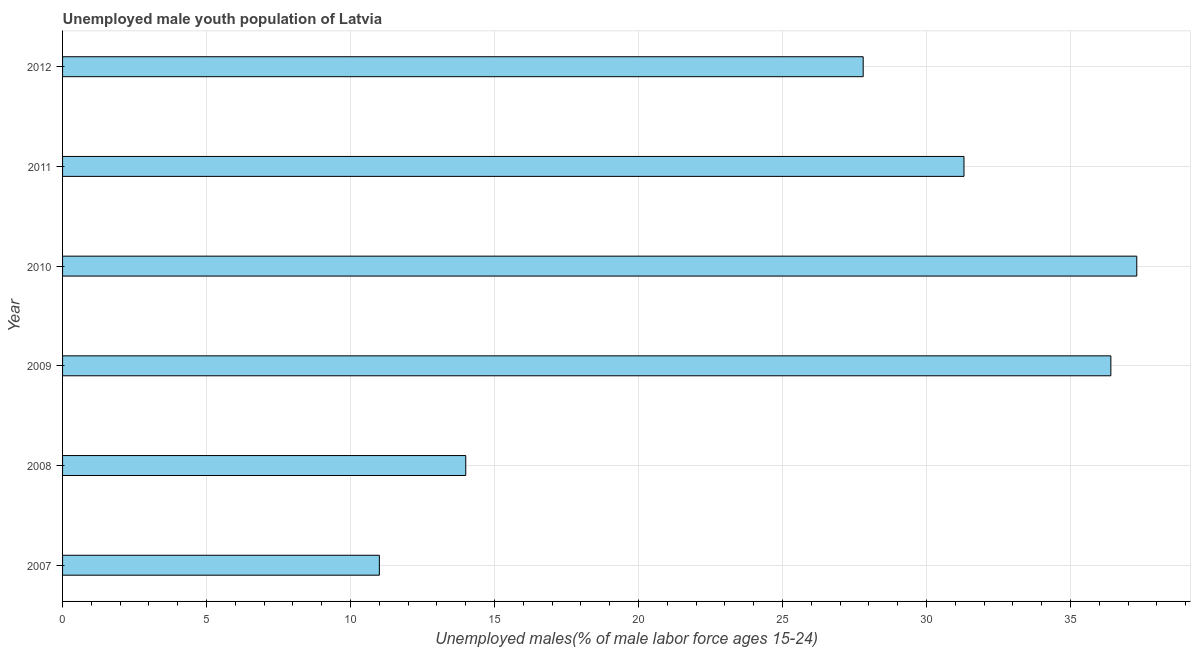Does the graph contain any zero values?
Offer a very short reply. No. Does the graph contain grids?
Make the answer very short. Yes. What is the title of the graph?
Ensure brevity in your answer.  Unemployed male youth population of Latvia. What is the label or title of the X-axis?
Give a very brief answer. Unemployed males(% of male labor force ages 15-24). What is the unemployed male youth in 2010?
Give a very brief answer. 37.3. Across all years, what is the maximum unemployed male youth?
Make the answer very short. 37.3. What is the sum of the unemployed male youth?
Offer a terse response. 157.8. What is the difference between the unemployed male youth in 2007 and 2011?
Offer a very short reply. -20.3. What is the average unemployed male youth per year?
Ensure brevity in your answer.  26.3. What is the median unemployed male youth?
Keep it short and to the point. 29.55. Do a majority of the years between 2008 and 2012 (inclusive) have unemployed male youth greater than 27 %?
Your response must be concise. Yes. What is the ratio of the unemployed male youth in 2010 to that in 2012?
Make the answer very short. 1.34. Is the unemployed male youth in 2009 less than that in 2012?
Offer a terse response. No. What is the difference between the highest and the second highest unemployed male youth?
Offer a terse response. 0.9. What is the difference between the highest and the lowest unemployed male youth?
Your response must be concise. 26.3. In how many years, is the unemployed male youth greater than the average unemployed male youth taken over all years?
Offer a terse response. 4. How many bars are there?
Provide a short and direct response. 6. How many years are there in the graph?
Your answer should be very brief. 6. What is the difference between two consecutive major ticks on the X-axis?
Provide a succinct answer. 5. What is the Unemployed males(% of male labor force ages 15-24) of 2007?
Offer a very short reply. 11. What is the Unemployed males(% of male labor force ages 15-24) of 2009?
Give a very brief answer. 36.4. What is the Unemployed males(% of male labor force ages 15-24) of 2010?
Your answer should be very brief. 37.3. What is the Unemployed males(% of male labor force ages 15-24) in 2011?
Offer a terse response. 31.3. What is the Unemployed males(% of male labor force ages 15-24) of 2012?
Ensure brevity in your answer.  27.8. What is the difference between the Unemployed males(% of male labor force ages 15-24) in 2007 and 2008?
Give a very brief answer. -3. What is the difference between the Unemployed males(% of male labor force ages 15-24) in 2007 and 2009?
Your answer should be compact. -25.4. What is the difference between the Unemployed males(% of male labor force ages 15-24) in 2007 and 2010?
Keep it short and to the point. -26.3. What is the difference between the Unemployed males(% of male labor force ages 15-24) in 2007 and 2011?
Offer a terse response. -20.3. What is the difference between the Unemployed males(% of male labor force ages 15-24) in 2007 and 2012?
Your answer should be compact. -16.8. What is the difference between the Unemployed males(% of male labor force ages 15-24) in 2008 and 2009?
Your answer should be very brief. -22.4. What is the difference between the Unemployed males(% of male labor force ages 15-24) in 2008 and 2010?
Your answer should be very brief. -23.3. What is the difference between the Unemployed males(% of male labor force ages 15-24) in 2008 and 2011?
Offer a very short reply. -17.3. What is the difference between the Unemployed males(% of male labor force ages 15-24) in 2009 and 2010?
Provide a short and direct response. -0.9. What is the difference between the Unemployed males(% of male labor force ages 15-24) in 2009 and 2011?
Give a very brief answer. 5.1. What is the difference between the Unemployed males(% of male labor force ages 15-24) in 2009 and 2012?
Make the answer very short. 8.6. What is the difference between the Unemployed males(% of male labor force ages 15-24) in 2010 and 2012?
Your response must be concise. 9.5. What is the ratio of the Unemployed males(% of male labor force ages 15-24) in 2007 to that in 2008?
Offer a very short reply. 0.79. What is the ratio of the Unemployed males(% of male labor force ages 15-24) in 2007 to that in 2009?
Offer a terse response. 0.3. What is the ratio of the Unemployed males(% of male labor force ages 15-24) in 2007 to that in 2010?
Your response must be concise. 0.29. What is the ratio of the Unemployed males(% of male labor force ages 15-24) in 2007 to that in 2011?
Offer a terse response. 0.35. What is the ratio of the Unemployed males(% of male labor force ages 15-24) in 2007 to that in 2012?
Give a very brief answer. 0.4. What is the ratio of the Unemployed males(% of male labor force ages 15-24) in 2008 to that in 2009?
Ensure brevity in your answer.  0.39. What is the ratio of the Unemployed males(% of male labor force ages 15-24) in 2008 to that in 2010?
Offer a very short reply. 0.38. What is the ratio of the Unemployed males(% of male labor force ages 15-24) in 2008 to that in 2011?
Provide a succinct answer. 0.45. What is the ratio of the Unemployed males(% of male labor force ages 15-24) in 2008 to that in 2012?
Give a very brief answer. 0.5. What is the ratio of the Unemployed males(% of male labor force ages 15-24) in 2009 to that in 2011?
Your answer should be very brief. 1.16. What is the ratio of the Unemployed males(% of male labor force ages 15-24) in 2009 to that in 2012?
Make the answer very short. 1.31. What is the ratio of the Unemployed males(% of male labor force ages 15-24) in 2010 to that in 2011?
Make the answer very short. 1.19. What is the ratio of the Unemployed males(% of male labor force ages 15-24) in 2010 to that in 2012?
Your answer should be compact. 1.34. What is the ratio of the Unemployed males(% of male labor force ages 15-24) in 2011 to that in 2012?
Offer a very short reply. 1.13. 